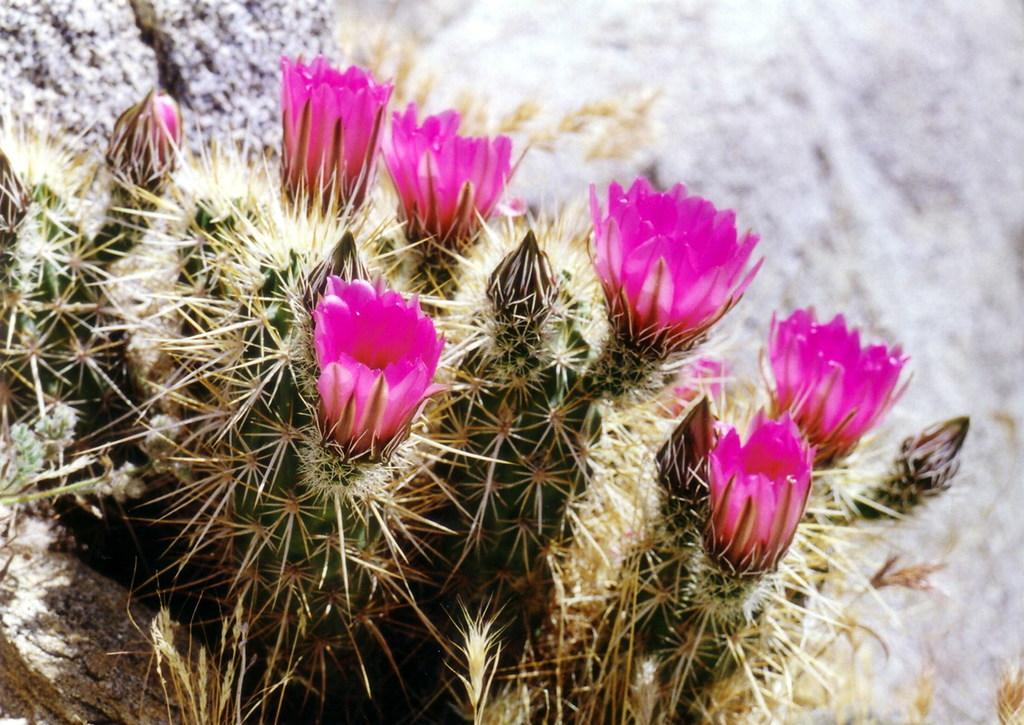What type of living organisms can be seen in the image? There are flowers in the image. What feature of the plant is also visible in the image? There are thorns in the image. To which part of the plant do the flowers and thorns belong? The flowers and thorns belong to a plant. What type of canvas is used to create the bed in the image? There is no canvas or bed present in the image; it features flowers and thorns belonging to a plant. 